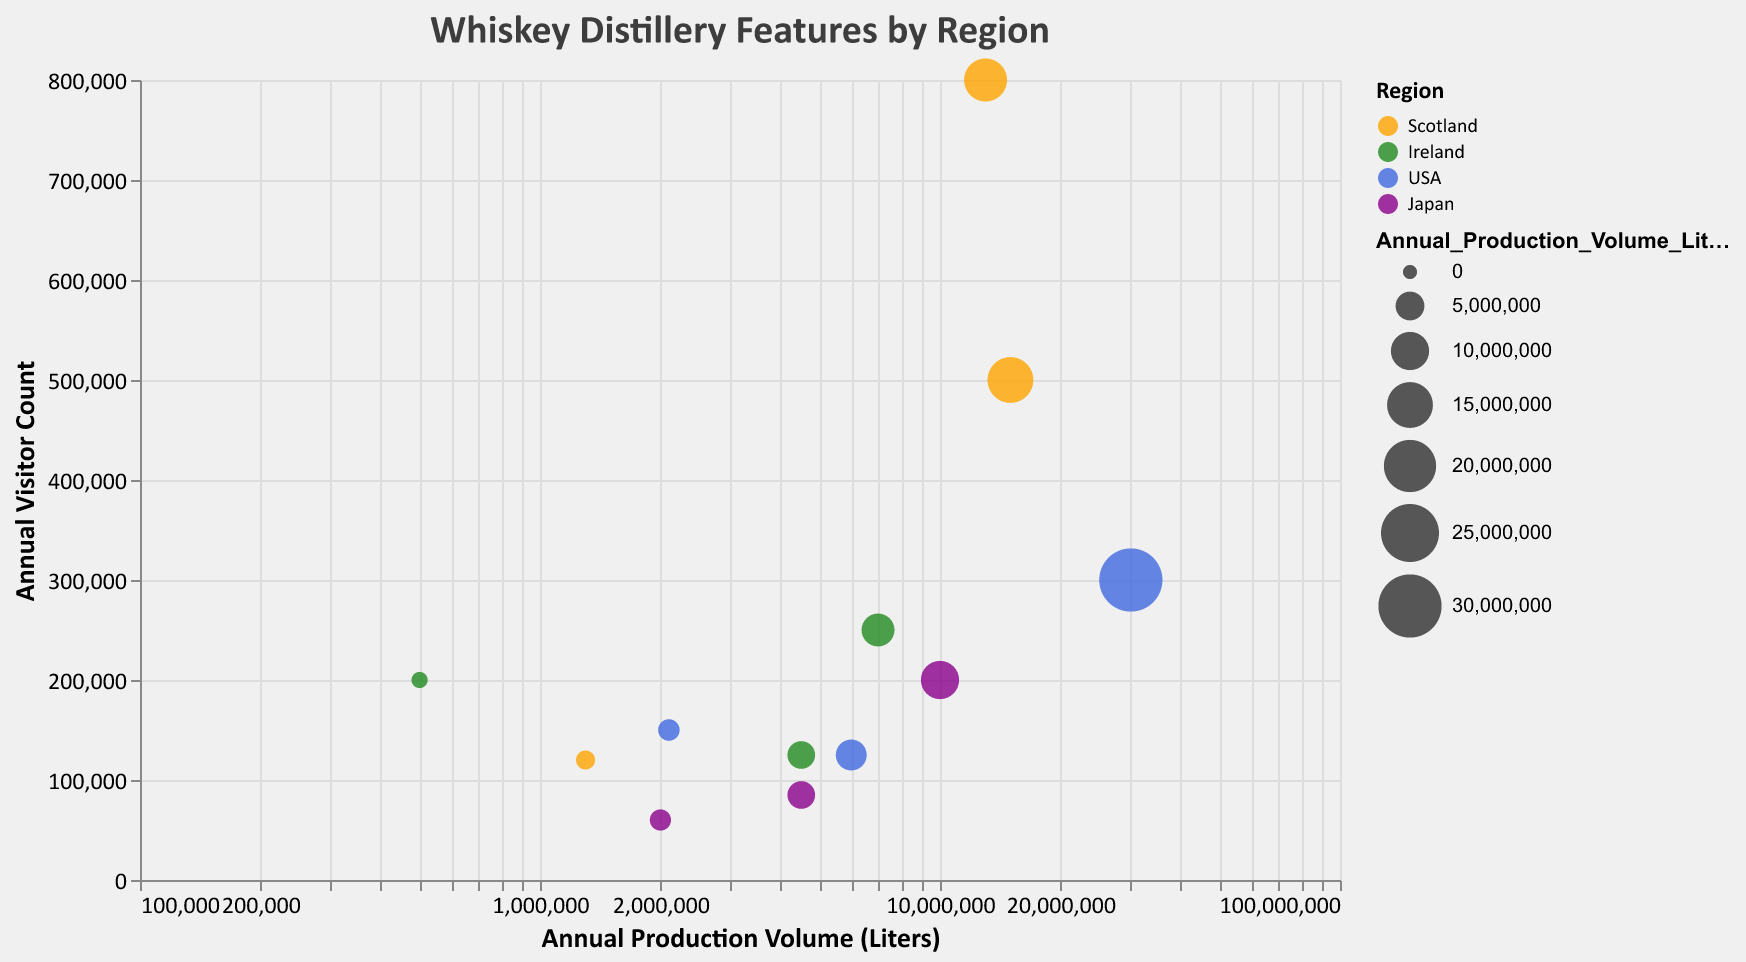What is the title of the chart? The title can be found at the top of the chart.
Answer: Whiskey Distillery Features by Region Which region has the distillery with the highest annual production volume? The largest bubble along the x-axis (Annual Production Volume) identifies this. The largest bubble belongs to Jack Daniel's in the USA.
Answer: USA Which distillery has the highest annual visitor count? The highest point along the y-axis (Visitor Count) shows the distillery. Glenfiddich in Scotland is the highest.
Answer: Glenfiddich How many distilleries from Japan are included in the chart? Count the number of bubbles colored with the color code for Japan.
Answer: 3 Which distillery in Ireland has the lowest annual production volume? Inspect the bubbles in the color code for Ireland and find the smallest along the x-axis.
Answer: Teeling What is the average annual visitor count of the distilleries in Scotland? Add the visitor counts of all the distilleries in Scotland and divide by the number of distilleries (3). (500,000 + 120,000 + 800,000) / 3 = 1,420,000 / 3 = 473,333
Answer: 473,333 What is the difference in annual production volume between Yamazaki and Macallan? Subtract the annual production volume of Yamazaki from that of Macallan. 15,000,000 - 10,000,000 = 5,000,000
Answer: 5,000,000 Which region has the most consistent distillery visitor counts (least variation)? Compare the range of visitor counts within each region to identify the region with the smallest variation. Ireland shows relatively small variation between the counts of 125,000, 200,000, and 250,000.
Answer: Ireland Which distillery has the largest bubble size and what does it represent? The largest bubble on the chart needs to be identified, and its corresponding tooltip will show the distillery and specify that the size represents annual production volume. The largest bubble is Jack Daniel's.
Answer: Jack Daniel's, Annual Production Volume Which Japanese distillery has the lowest annual visitor count? Find the smallest point along the y-axis among the bubbles with the color code for Japan.
Answer: Yoichi 